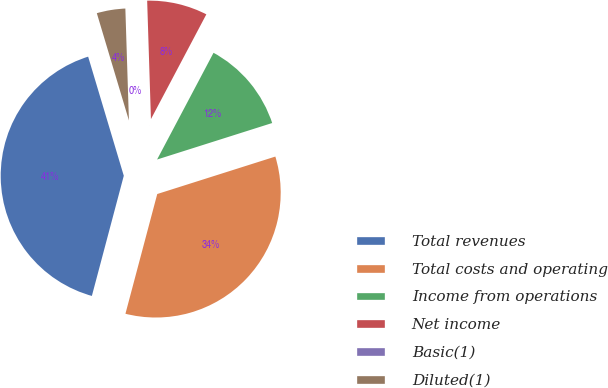Convert chart. <chart><loc_0><loc_0><loc_500><loc_500><pie_chart><fcel>Total revenues<fcel>Total costs and operating<fcel>Income from operations<fcel>Net income<fcel>Basic(1)<fcel>Diluted(1)<nl><fcel>41.24%<fcel>34.02%<fcel>12.37%<fcel>8.25%<fcel>0.0%<fcel>4.12%<nl></chart> 